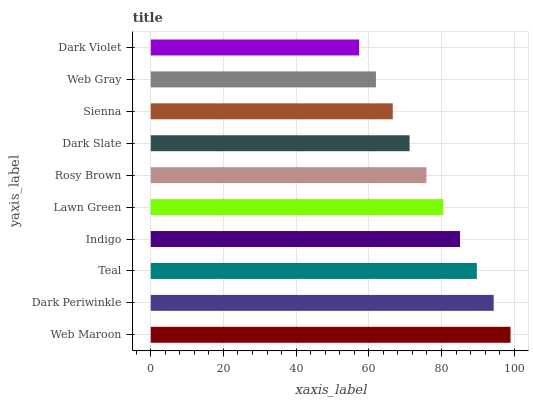Is Dark Violet the minimum?
Answer yes or no. Yes. Is Web Maroon the maximum?
Answer yes or no. Yes. Is Dark Periwinkle the minimum?
Answer yes or no. No. Is Dark Periwinkle the maximum?
Answer yes or no. No. Is Web Maroon greater than Dark Periwinkle?
Answer yes or no. Yes. Is Dark Periwinkle less than Web Maroon?
Answer yes or no. Yes. Is Dark Periwinkle greater than Web Maroon?
Answer yes or no. No. Is Web Maroon less than Dark Periwinkle?
Answer yes or no. No. Is Lawn Green the high median?
Answer yes or no. Yes. Is Rosy Brown the low median?
Answer yes or no. Yes. Is Web Maroon the high median?
Answer yes or no. No. Is Teal the low median?
Answer yes or no. No. 